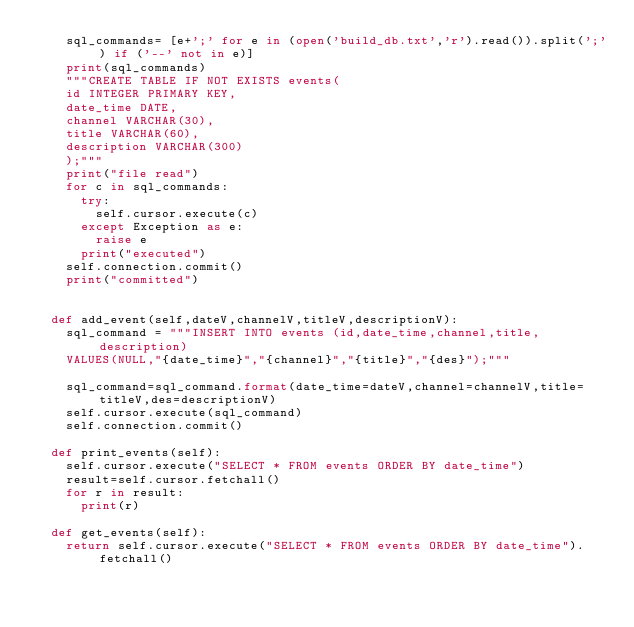<code> <loc_0><loc_0><loc_500><loc_500><_Python_>		sql_commands= [e+';' for e in (open('build_db.txt','r').read()).split(';') if ('--' not in e)]
		print(sql_commands)
		"""CREATE TABLE IF NOT EXISTS events(
		id INTEGER PRIMARY KEY,
		date_time DATE,
		channel VARCHAR(30),
		title VARCHAR(60),
		description VARCHAR(300)
		);"""
		print("file read")
		for c in sql_commands:
			try:
				self.cursor.execute(c)
			except Exception as e:
				raise e
			print("executed")
		self.connection.commit()
		print("committed")


	def add_event(self,dateV,channelV,titleV,descriptionV):
		sql_command = """INSERT INTO events (id,date_time,channel,title,description)
		VALUES(NULL,"{date_time}","{channel}","{title}","{des}");"""

		sql_command=sql_command.format(date_time=dateV,channel=channelV,title=titleV,des=descriptionV)
		self.cursor.execute(sql_command)
		self.connection.commit()

	def print_events(self):
		self.cursor.execute("SELECT * FROM events ORDER BY date_time")
		result=self.cursor.fetchall()
		for r in result:
			print(r)

	def get_events(self):
		return self.cursor.execute("SELECT * FROM events ORDER BY date_time").fetchall()
</code> 